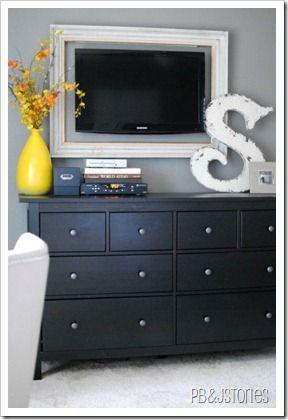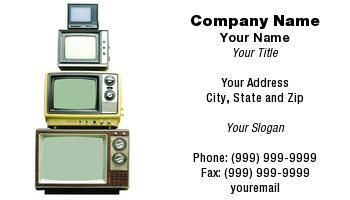The first image is the image on the left, the second image is the image on the right. Examine the images to the left and right. Is the description "One image includes only a single television set." accurate? Answer yes or no. Yes. The first image is the image on the left, the second image is the image on the right. Given the left and right images, does the statement "An image includes a vertical stack of four TVs, stacked from the biggest on the bottom to the smallest on top." hold true? Answer yes or no. Yes. 